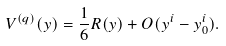<formula> <loc_0><loc_0><loc_500><loc_500>V ^ { ( q ) } ( y ) = \frac { 1 } { 6 } R ( y ) + O ( y ^ { i } - y _ { 0 } ^ { i } ) .</formula> 